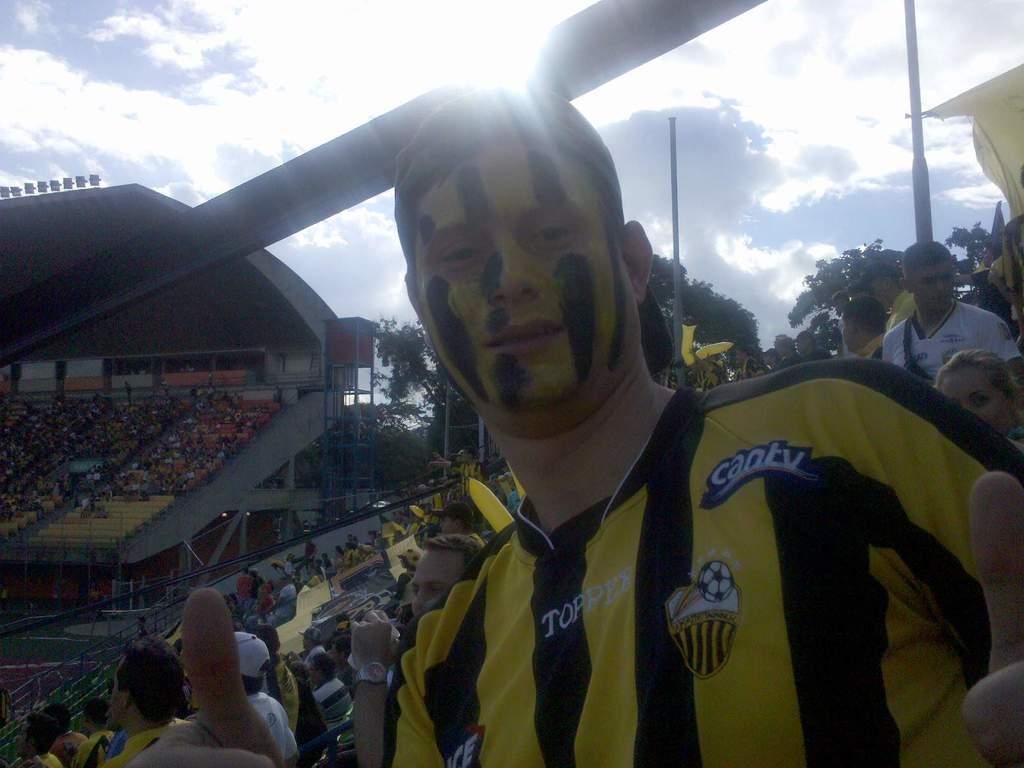What does the patch near the fan's left shoulder say?
Your answer should be very brief. Cantv. 